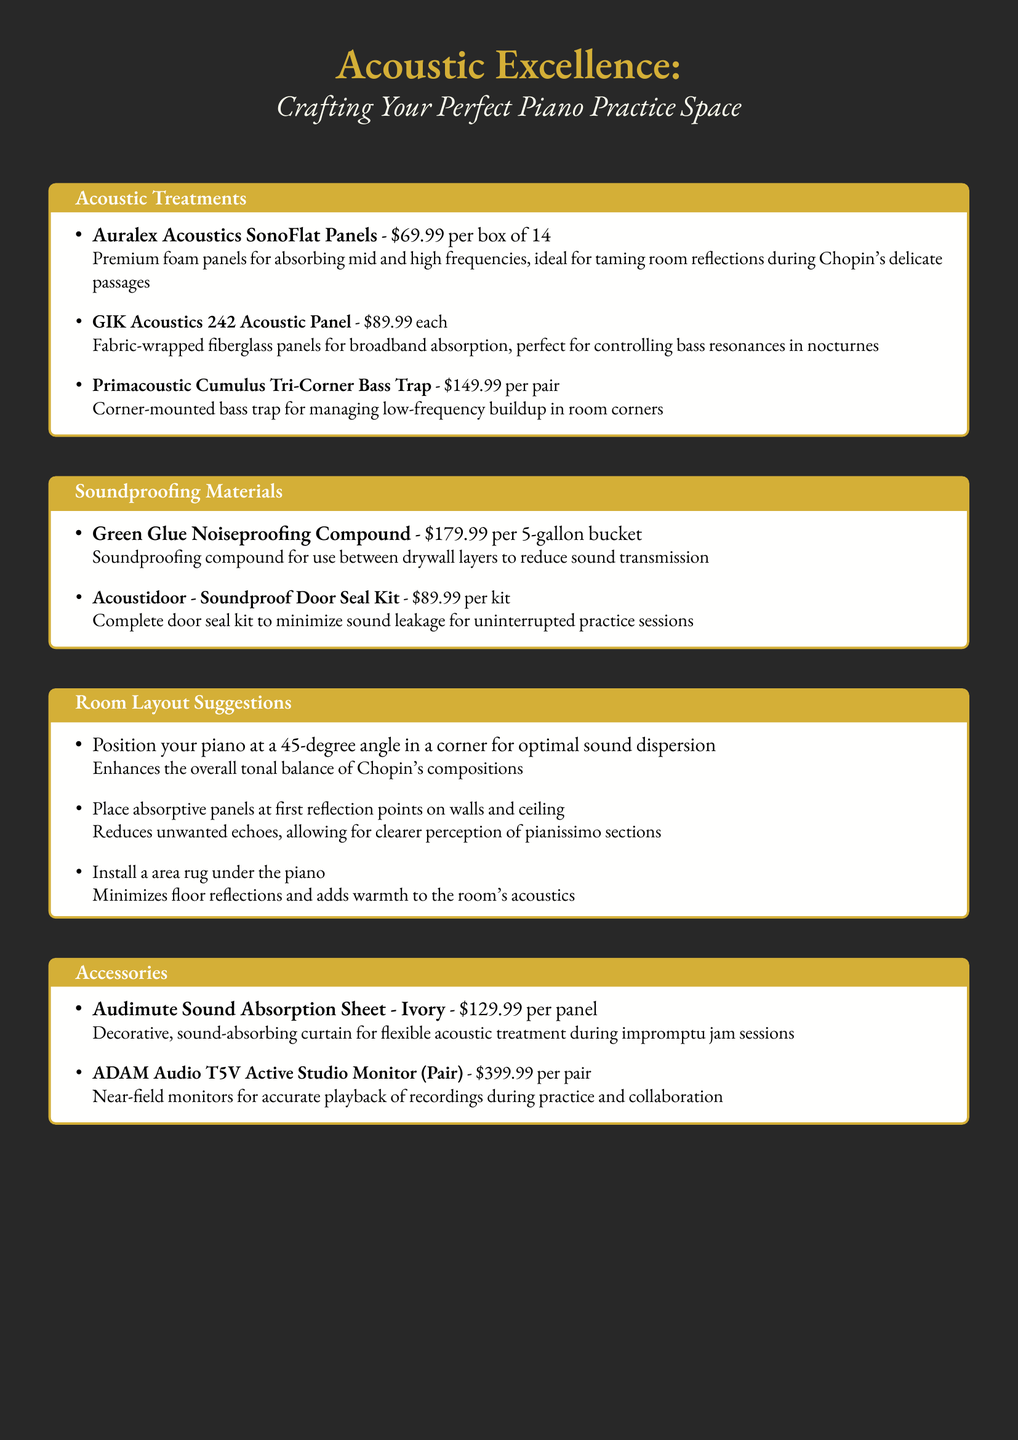What is the price of Auralex Acoustics SonoFlat Panels? The price for Auralex Acoustics SonoFlat Panels is mentioned in the document as $69.99 per box of 14.
Answer: $69.99 per box of 14 How much does a Green Glue Noiseproofing Compound cost? The document states that the price of Green Glue Noiseproofing Compound is $179.99 per 5-gallon bucket.
Answer: $179.99 per 5-gallon bucket What type of panel is the GIK Acoustics 242 Acoustic Panel? Auralex Acoustics SonoFlat Panels are described as premium foam panels for absorbing mid and high frequencies.
Answer: Fabric-wrapped fiberglass panels How should the piano be positioned according to the layout suggestions? The document recommends positioning the piano at a 45-degree angle in a corner for optimal sound dispersion.
Answer: 45-degree angle in a corner What accessory is described as a decorative sound absorption sheet? The accessory mentioned in the document that serves as a decorative sound absorption sheet is the Audimute Sound Absorption Sheet.
Answer: Audimute Sound Absorption Sheet What does the Acoustidoor Soundproof Door Seal Kit minimize? The document states that it minimizes sound leakage for uninterrupted practice sessions.
Answer: Sound leakage What is the suggested installation location for absorptive panels? According to the room layout suggestions, absorptive panels should be placed at first reflection points on walls and ceiling.
Answer: First reflection points on walls and ceiling 